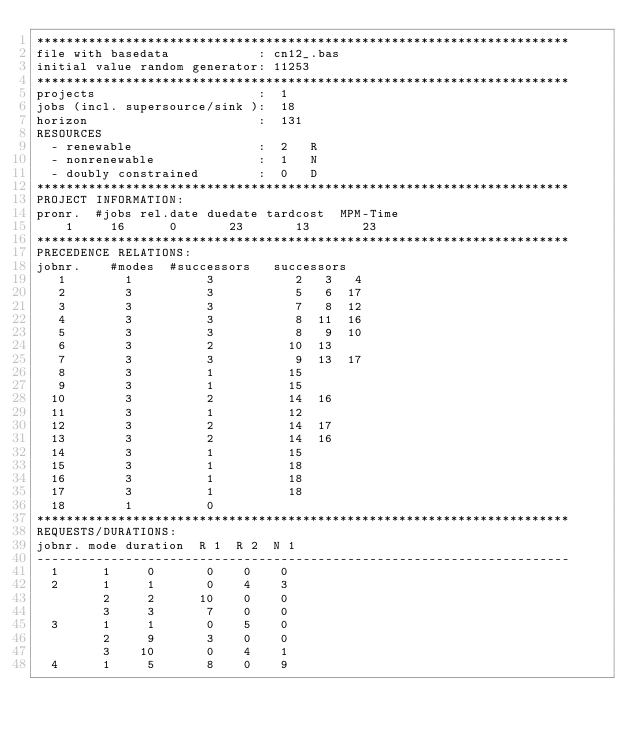Convert code to text. <code><loc_0><loc_0><loc_500><loc_500><_ObjectiveC_>************************************************************************
file with basedata            : cn12_.bas
initial value random generator: 11253
************************************************************************
projects                      :  1
jobs (incl. supersource/sink ):  18
horizon                       :  131
RESOURCES
  - renewable                 :  2   R
  - nonrenewable              :  1   N
  - doubly constrained        :  0   D
************************************************************************
PROJECT INFORMATION:
pronr.  #jobs rel.date duedate tardcost  MPM-Time
    1     16      0       23       13       23
************************************************************************
PRECEDENCE RELATIONS:
jobnr.    #modes  #successors   successors
   1        1          3           2   3   4
   2        3          3           5   6  17
   3        3          3           7   8  12
   4        3          3           8  11  16
   5        3          3           8   9  10
   6        3          2          10  13
   7        3          3           9  13  17
   8        3          1          15
   9        3          1          15
  10        3          2          14  16
  11        3          1          12
  12        3          2          14  17
  13        3          2          14  16
  14        3          1          15
  15        3          1          18
  16        3          1          18
  17        3          1          18
  18        1          0        
************************************************************************
REQUESTS/DURATIONS:
jobnr. mode duration  R 1  R 2  N 1
------------------------------------------------------------------------
  1      1     0       0    0    0
  2      1     1       0    4    3
         2     2      10    0    0
         3     3       7    0    0
  3      1     1       0    5    0
         2     9       3    0    0
         3    10       0    4    1
  4      1     5       8    0    9</code> 